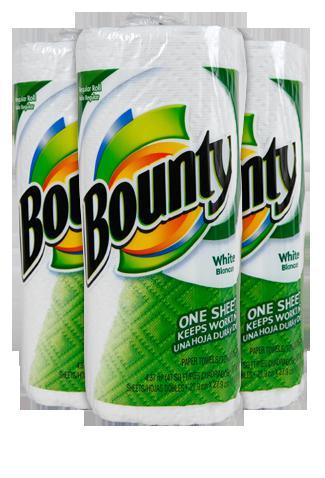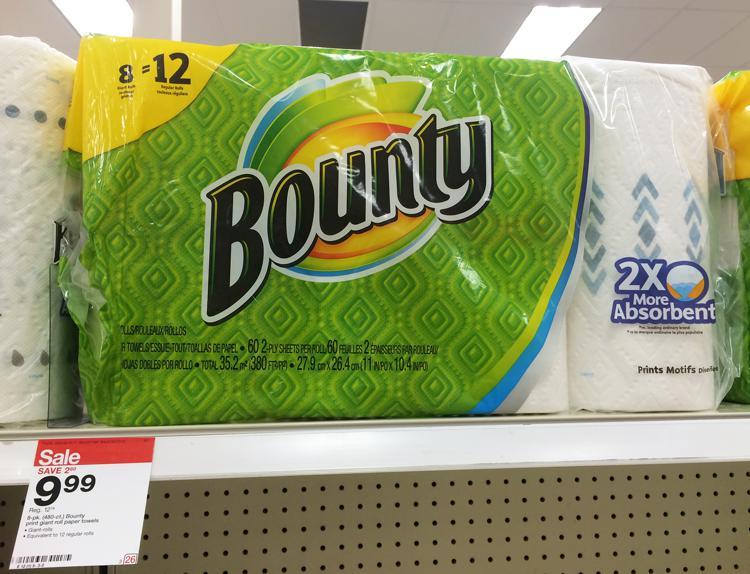The first image is the image on the left, the second image is the image on the right. Given the left and right images, does the statement "Right image shows a pack of paper towels on a store shelf with pegboard and a price sign visible." hold true? Answer yes or no. Yes. 